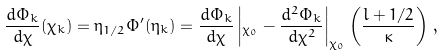Convert formula to latex. <formula><loc_0><loc_0><loc_500><loc_500>\frac { d \Phi _ { k } } { d \chi } ( \chi _ { k } ) = \eta _ { 1 / 2 } \Phi ^ { \prime } ( \eta _ { k } ) = \frac { d \Phi _ { k } } { d \chi } \left | _ { \chi _ { 0 } } - \frac { d ^ { 2 } \Phi _ { k } } { d \chi ^ { 2 } } \right | _ { \chi _ { 0 } } \left ( \frac { l + 1 / 2 } { \kappa } \right ) \, ,</formula> 